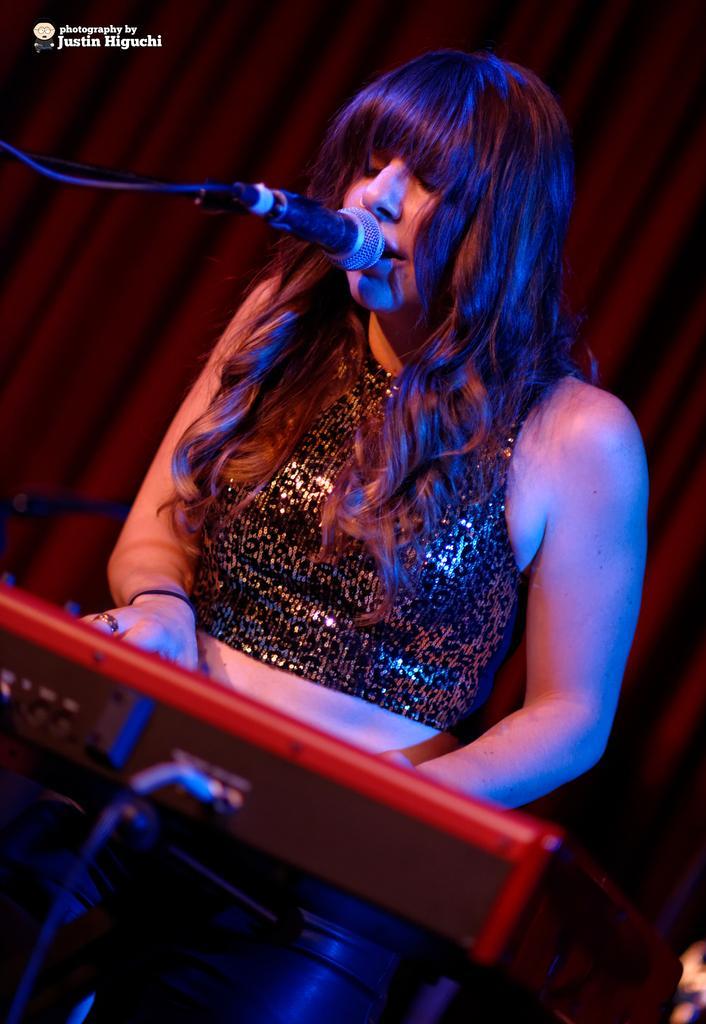Could you give a brief overview of what you see in this image? In this image there is a woman playing keyboard, in front of her there is a mic, in the background there is a curtain. 